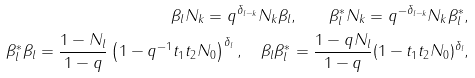<formula> <loc_0><loc_0><loc_500><loc_500>\beta _ { l } N _ { k } = q ^ { \delta _ { l - k } } N _ { k } \beta _ { l } , \quad \beta _ { l } ^ { * } N _ { k } = q ^ { - \delta _ { l - k } } N _ { k } \beta _ { l } ^ { * } , \\ \beta _ { l } ^ { * } \beta _ { l } = \frac { 1 - N _ { l } } { 1 - q } \left ( 1 - q ^ { - 1 } t _ { 1 } t _ { 2 } N _ { 0 } \right ) ^ { \delta _ { l } } , \quad \beta _ { l } \beta _ { l } ^ { * } = \frac { 1 - q N _ { l } } { 1 - q } ( 1 - t _ { 1 } t _ { 2 } N _ { 0 } ) ^ { \delta _ { l } } ,</formula> 